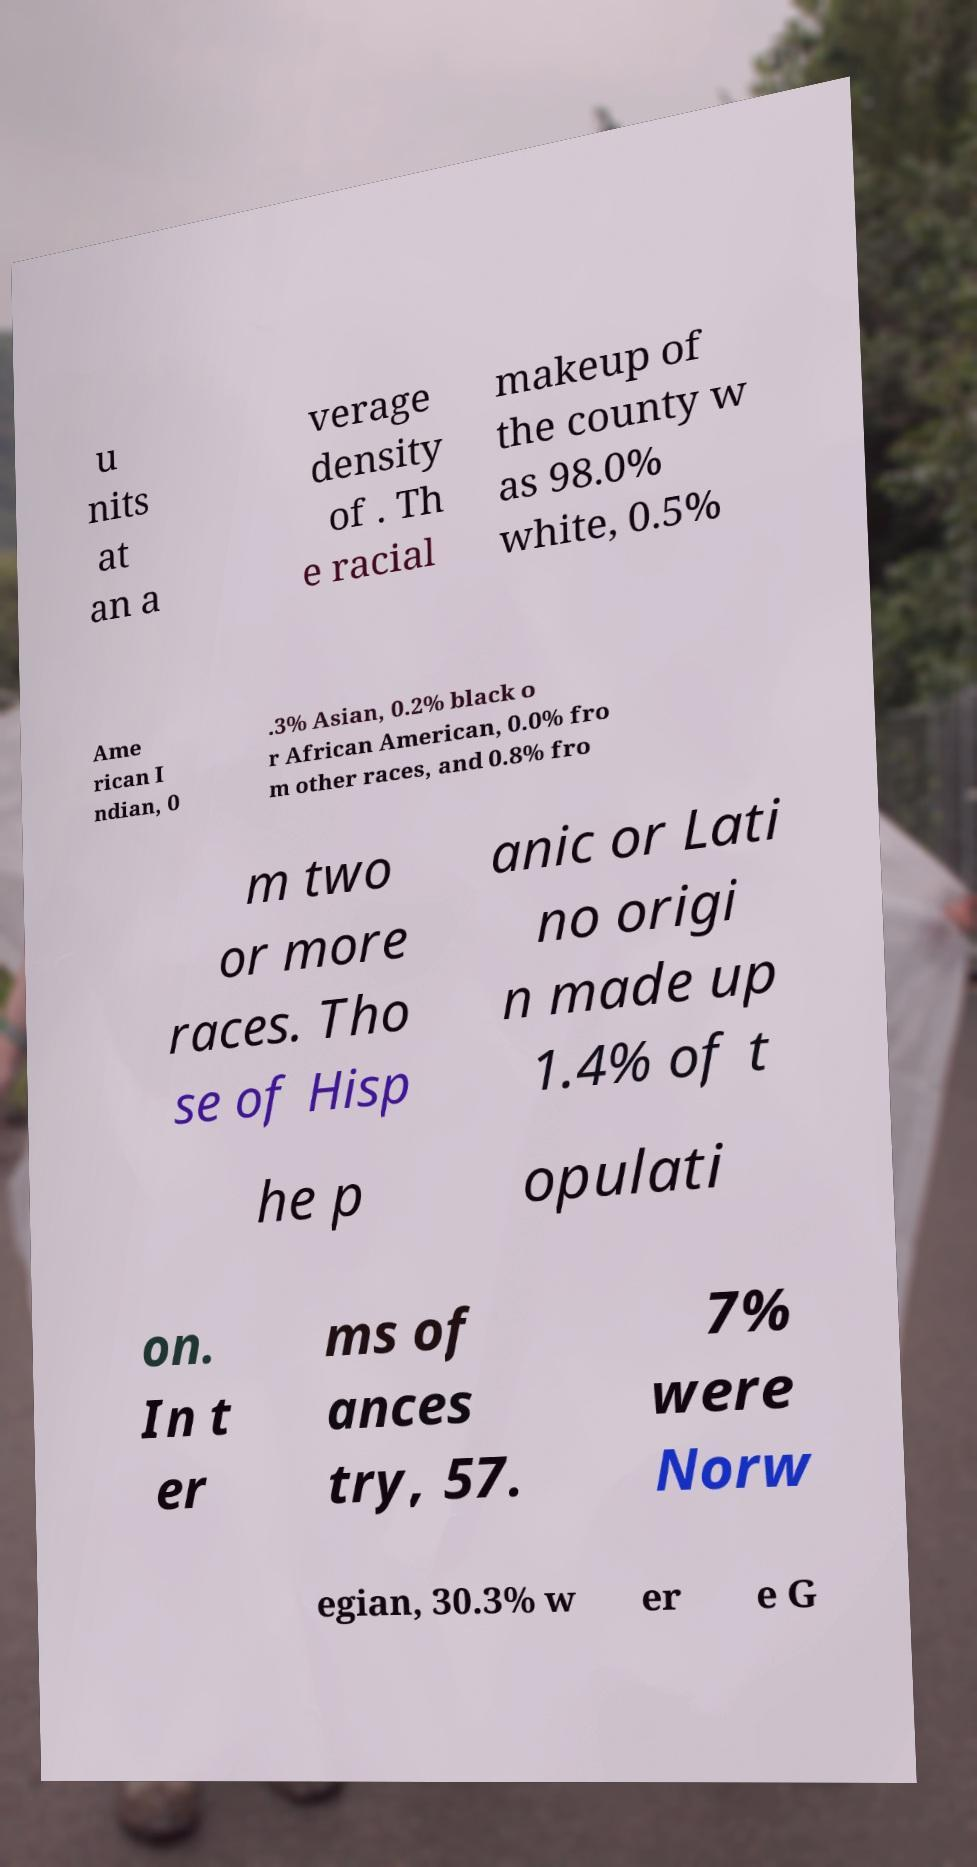Please identify and transcribe the text found in this image. u nits at an a verage density of . Th e racial makeup of the county w as 98.0% white, 0.5% Ame rican I ndian, 0 .3% Asian, 0.2% black o r African American, 0.0% fro m other races, and 0.8% fro m two or more races. Tho se of Hisp anic or Lati no origi n made up 1.4% of t he p opulati on. In t er ms of ances try, 57. 7% were Norw egian, 30.3% w er e G 